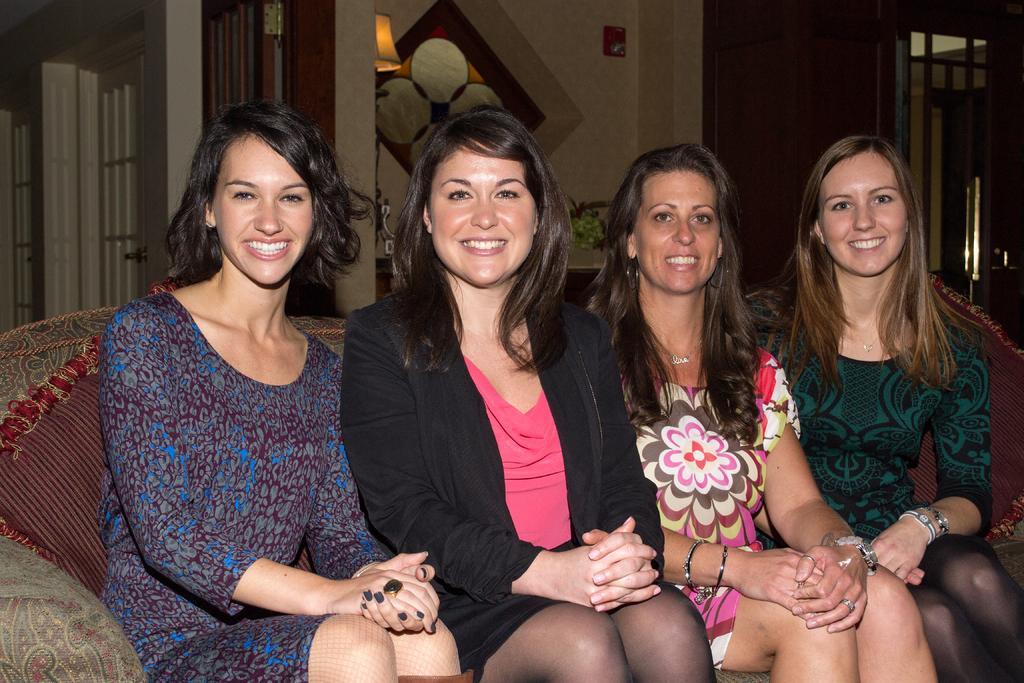Please provide a concise description of this image. In this image there are four women sitting and smiling, and they are sitting on a couch. On the couch there are pillows, and in the background there is wall, windows, lamp, photo frame and a table. On the table there are some objects. 